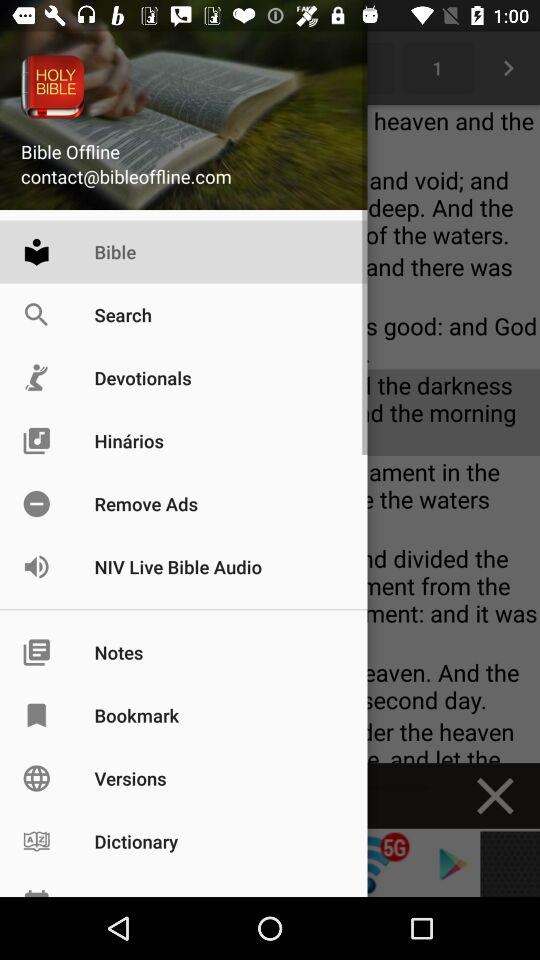How many bookmarks are there?
When the provided information is insufficient, respond with <no answer>. <no answer> 